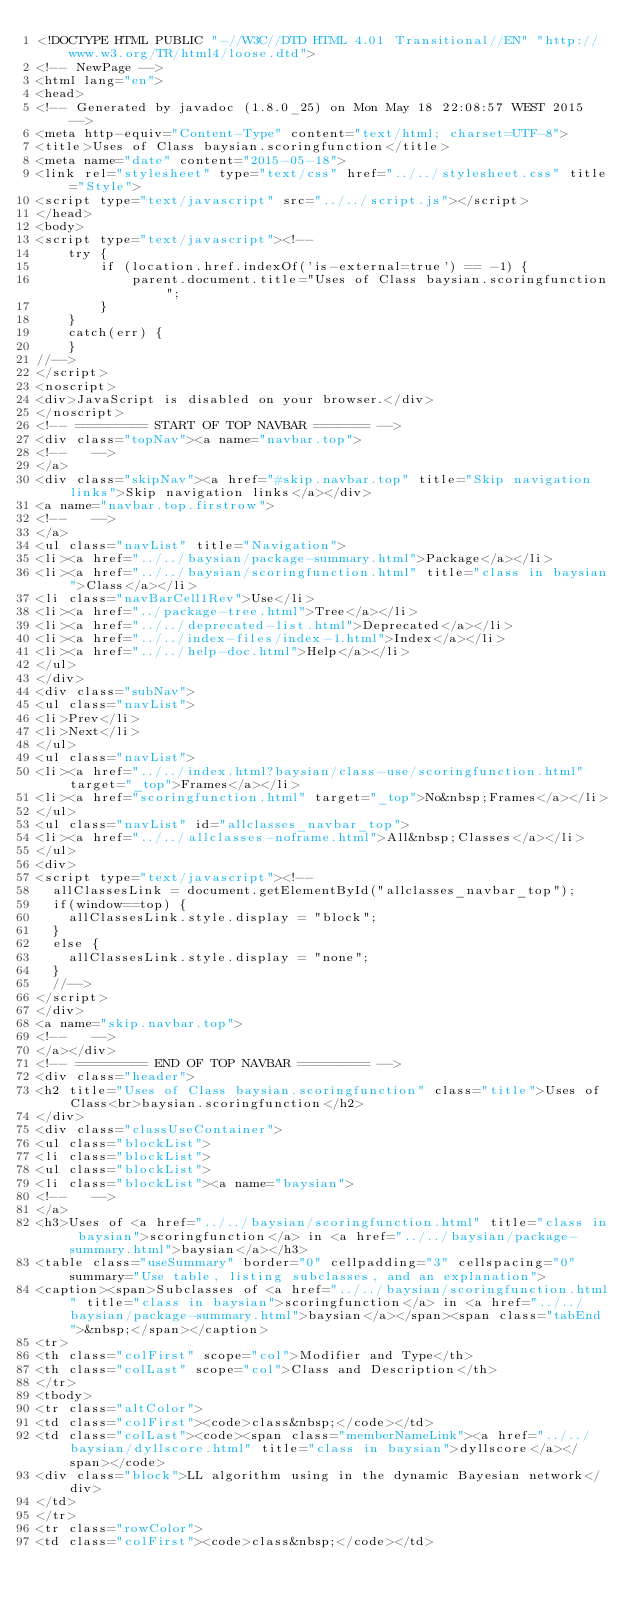Convert code to text. <code><loc_0><loc_0><loc_500><loc_500><_HTML_><!DOCTYPE HTML PUBLIC "-//W3C//DTD HTML 4.01 Transitional//EN" "http://www.w3.org/TR/html4/loose.dtd">
<!-- NewPage -->
<html lang="en">
<head>
<!-- Generated by javadoc (1.8.0_25) on Mon May 18 22:08:57 WEST 2015 -->
<meta http-equiv="Content-Type" content="text/html; charset=UTF-8">
<title>Uses of Class baysian.scoringfunction</title>
<meta name="date" content="2015-05-18">
<link rel="stylesheet" type="text/css" href="../../stylesheet.css" title="Style">
<script type="text/javascript" src="../../script.js"></script>
</head>
<body>
<script type="text/javascript"><!--
    try {
        if (location.href.indexOf('is-external=true') == -1) {
            parent.document.title="Uses of Class baysian.scoringfunction";
        }
    }
    catch(err) {
    }
//-->
</script>
<noscript>
<div>JavaScript is disabled on your browser.</div>
</noscript>
<!-- ========= START OF TOP NAVBAR ======= -->
<div class="topNav"><a name="navbar.top">
<!--   -->
</a>
<div class="skipNav"><a href="#skip.navbar.top" title="Skip navigation links">Skip navigation links</a></div>
<a name="navbar.top.firstrow">
<!--   -->
</a>
<ul class="navList" title="Navigation">
<li><a href="../../baysian/package-summary.html">Package</a></li>
<li><a href="../../baysian/scoringfunction.html" title="class in baysian">Class</a></li>
<li class="navBarCell1Rev">Use</li>
<li><a href="../package-tree.html">Tree</a></li>
<li><a href="../../deprecated-list.html">Deprecated</a></li>
<li><a href="../../index-files/index-1.html">Index</a></li>
<li><a href="../../help-doc.html">Help</a></li>
</ul>
</div>
<div class="subNav">
<ul class="navList">
<li>Prev</li>
<li>Next</li>
</ul>
<ul class="navList">
<li><a href="../../index.html?baysian/class-use/scoringfunction.html" target="_top">Frames</a></li>
<li><a href="scoringfunction.html" target="_top">No&nbsp;Frames</a></li>
</ul>
<ul class="navList" id="allclasses_navbar_top">
<li><a href="../../allclasses-noframe.html">All&nbsp;Classes</a></li>
</ul>
<div>
<script type="text/javascript"><!--
  allClassesLink = document.getElementById("allclasses_navbar_top");
  if(window==top) {
    allClassesLink.style.display = "block";
  }
  else {
    allClassesLink.style.display = "none";
  }
  //-->
</script>
</div>
<a name="skip.navbar.top">
<!--   -->
</a></div>
<!-- ========= END OF TOP NAVBAR ========= -->
<div class="header">
<h2 title="Uses of Class baysian.scoringfunction" class="title">Uses of Class<br>baysian.scoringfunction</h2>
</div>
<div class="classUseContainer">
<ul class="blockList">
<li class="blockList">
<ul class="blockList">
<li class="blockList"><a name="baysian">
<!--   -->
</a>
<h3>Uses of <a href="../../baysian/scoringfunction.html" title="class in baysian">scoringfunction</a> in <a href="../../baysian/package-summary.html">baysian</a></h3>
<table class="useSummary" border="0" cellpadding="3" cellspacing="0" summary="Use table, listing subclasses, and an explanation">
<caption><span>Subclasses of <a href="../../baysian/scoringfunction.html" title="class in baysian">scoringfunction</a> in <a href="../../baysian/package-summary.html">baysian</a></span><span class="tabEnd">&nbsp;</span></caption>
<tr>
<th class="colFirst" scope="col">Modifier and Type</th>
<th class="colLast" scope="col">Class and Description</th>
</tr>
<tbody>
<tr class="altColor">
<td class="colFirst"><code>class&nbsp;</code></td>
<td class="colLast"><code><span class="memberNameLink"><a href="../../baysian/dyllscore.html" title="class in baysian">dyllscore</a></span></code>
<div class="block">LL algorithm using in the dynamic Bayesian network</div>
</td>
</tr>
<tr class="rowColor">
<td class="colFirst"><code>class&nbsp;</code></td></code> 